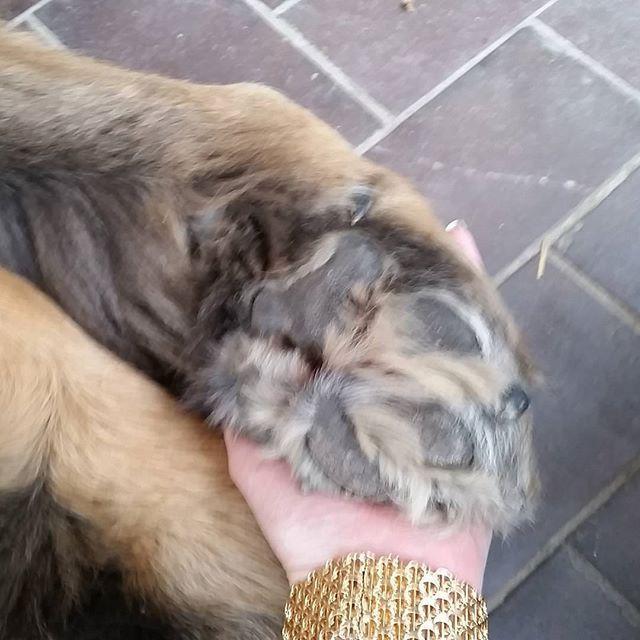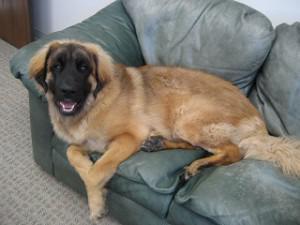The first image is the image on the left, the second image is the image on the right. For the images displayed, is the sentence "There is a human in the image on the right." factually correct? Answer yes or no. No. 